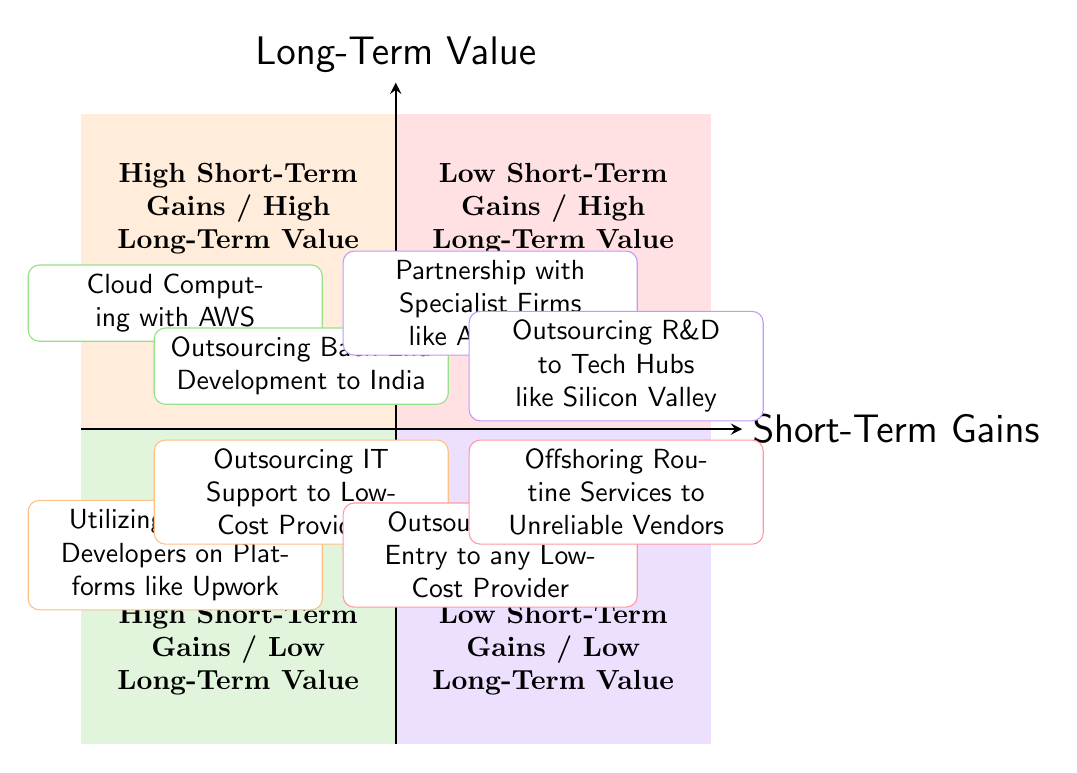What outsourcing option is located in the high short-term gains and high long-term value quadrant? The diagram clearly shows that "Cloud Computing with AWS" is positioned in the quadrant representing high short-term gains and high long-term value.
Answer: Cloud Computing with AWS How many outsourcing options are in the high short-term gains and low long-term value quadrant? By looking at the quadrant for high short-term gains and low long-term value, we can count two options: "Utilizing Freelance Developers on Platforms like Upwork" and "Outsourcing IT Support to Low-Cost Providers".
Answer: 2 Which outsourcing option has the least long-term value? The "Outsourcing Data Entry to any Low-Cost Provider" option is listed in the low short-term gains and low long-term value quadrant, indicating it has the least long-term value.
Answer: Outsourcing Data Entry to any Low-Cost Provider Which quadrant features outsourcing options that provide significant upfront investment? The quadrant that represents low short-term gains but high long-term value includes "Outsourcing R&D to Tech Hubs like Silicon Valley" and "Partnership with Specialist Firms like Accenture", both of which indicate significant upfront investment.
Answer: Low Short-Term Gains / High Long-Term Value What are the short-term gains listed for outsourcing IT support to low-cost providers? The diagram specifies that "Outsourcing IT Support to Low-Cost Providers" offers "Immediate reduction in operational expenses" as short-term gains.
Answer: Immediate reduction in operational expenses What is the key disadvantage listed for utilizing freelance developers? The diagram indicates that the key disadvantage associated with "Utilizing Freelance Developers on Platforms like Upwork" is "Inconsistent quality and limited commitment".
Answer: Inconsistent quality and limited commitment How many options are categorized as having both low short-term gains and low long-term value? Examining the corresponding quadrant, we find that there are a total of two options: "Outsourcing Data Entry to any Low-Cost Provider" and "Offshoring Routine Services to Unreliable Vendors".
Answer: 2 Which option has high initial cost but promises long-term value due to strategic expertise? The "Partnership with Specialist Firms like Accenture" is noted for its high initial costs while promising long-term strategic expertise and partnership value.
Answer: Partnership with Specialist Firms like Accenture 